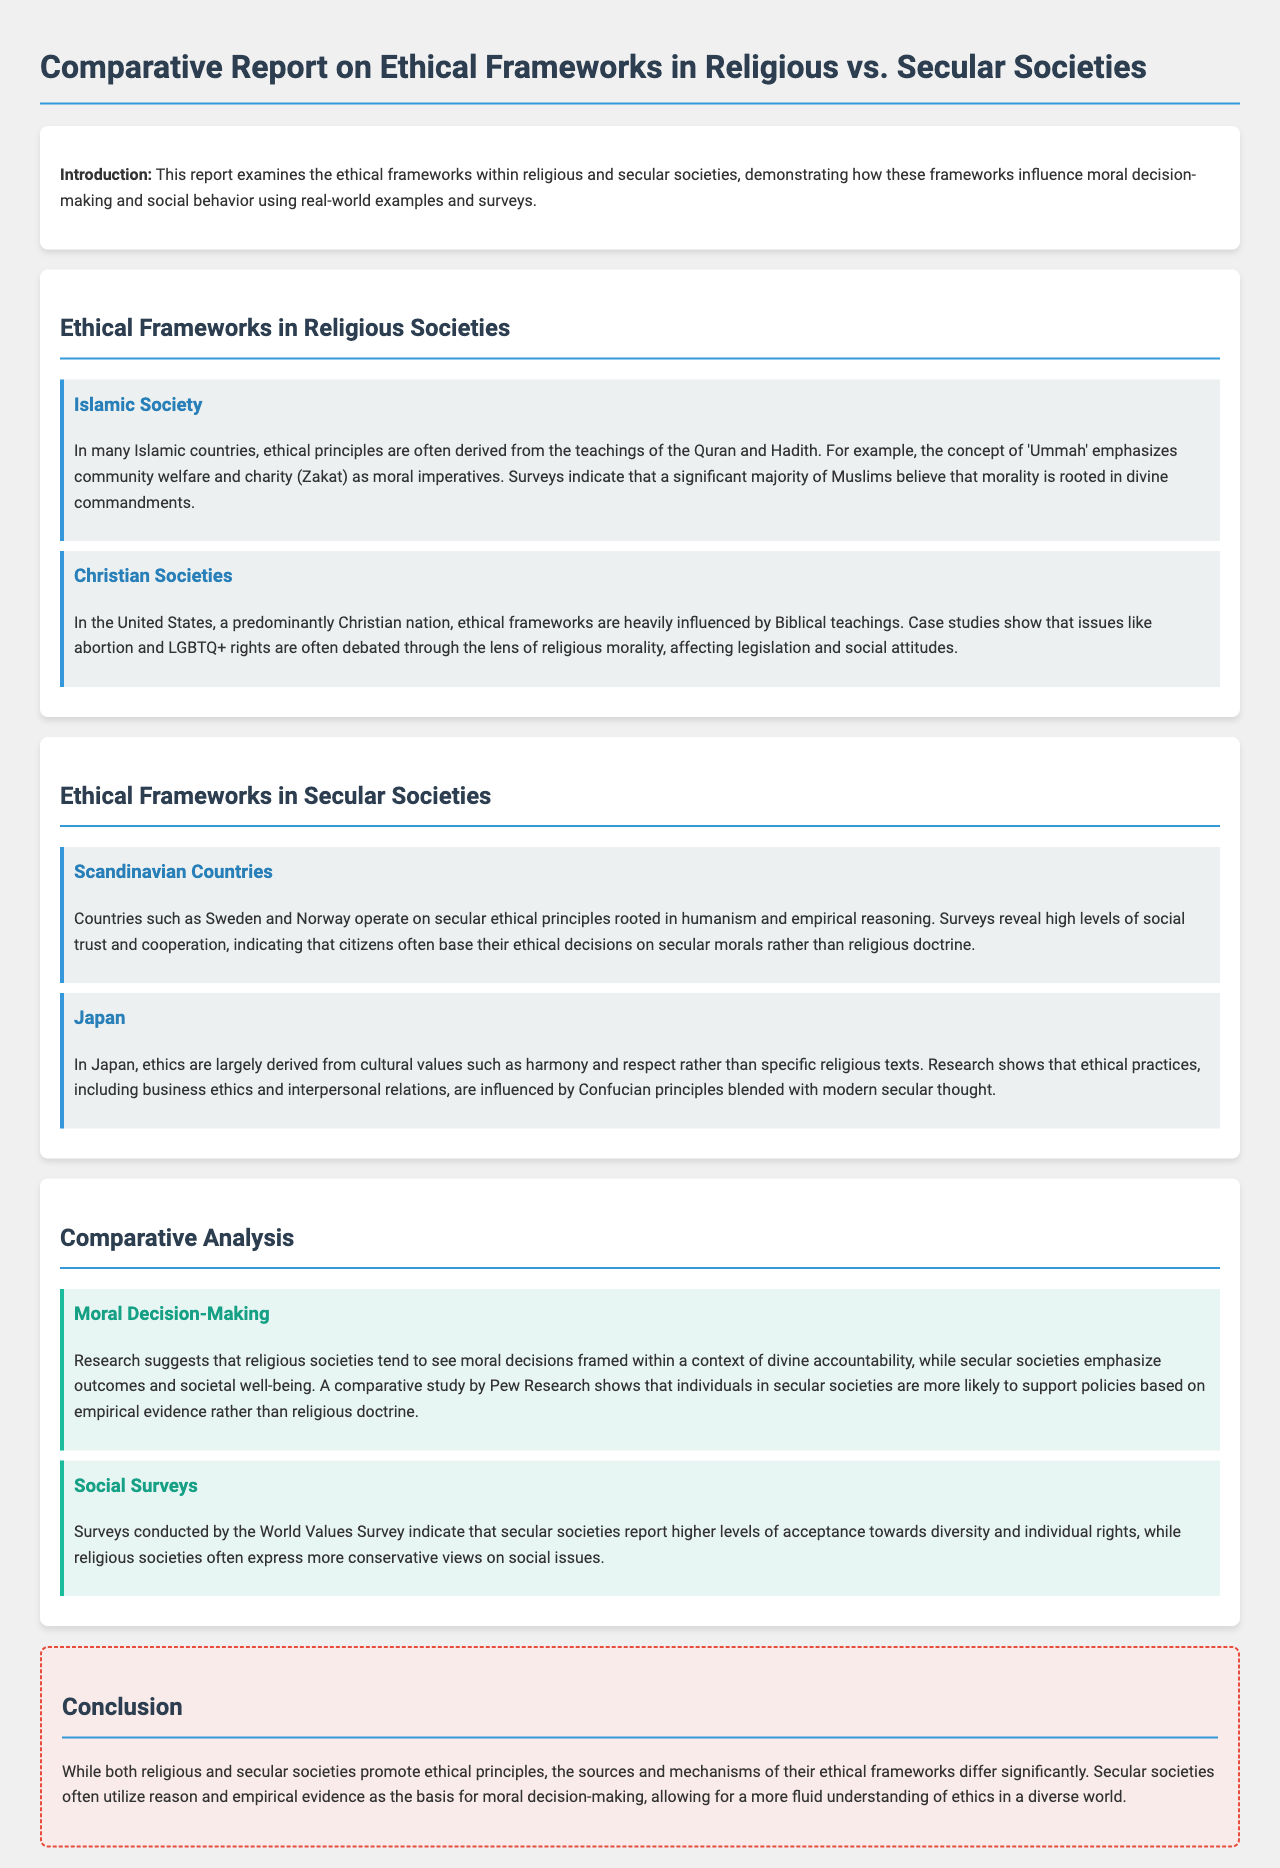What are the predominant religious influences in the United States? The predominant religious influences in the United States are Christian teachings.
Answer: Christian teachings What concept emphasizes community welfare and charity in Islamic societies? The concept that emphasizes community welfare and charity in Islamic societies is 'Ummah'.
Answer: 'Ummah' Which countries exemplify secular ethical principles rooted in humanism? The countries that exemplify secular ethical principles rooted in humanism are Sweden and Norway.
Answer: Sweden and Norway What is the primary basis for ethical practices in Japan according to the report? The primary basis for ethical practices in Japan is cultural values such as harmony and respect.
Answer: Cultural values such as harmony and respect How do decision-making approaches differ between religious and secular societies? Religious societies frame moral decisions within divine accountability, while secular societies emphasize outcomes and societal well-being.
Answer: Divine accountability vs. outcomes and societal well-being Which survey indicates higher acceptance towards diversity in societies? The survey indicating higher acceptance towards diversity in societies is the World Values Survey.
Answer: World Values Survey What does the conclusion state about the sources of ethical principles in societies? The conclusion states that the sources and mechanisms of ethical frameworks differ significantly between religious and secular societies.
Answer: Differ significantly How are policies supported in secular societies according to the comparative study? In secular societies, policies are supported based on empirical evidence rather than religious doctrine.
Answer: Empirical evidence What ethical imperative is highlighted in Islamic teachings? The ethical imperative highlighted in Islamic teachings is charity (Zakat).
Answer: Charity (Zakat) 